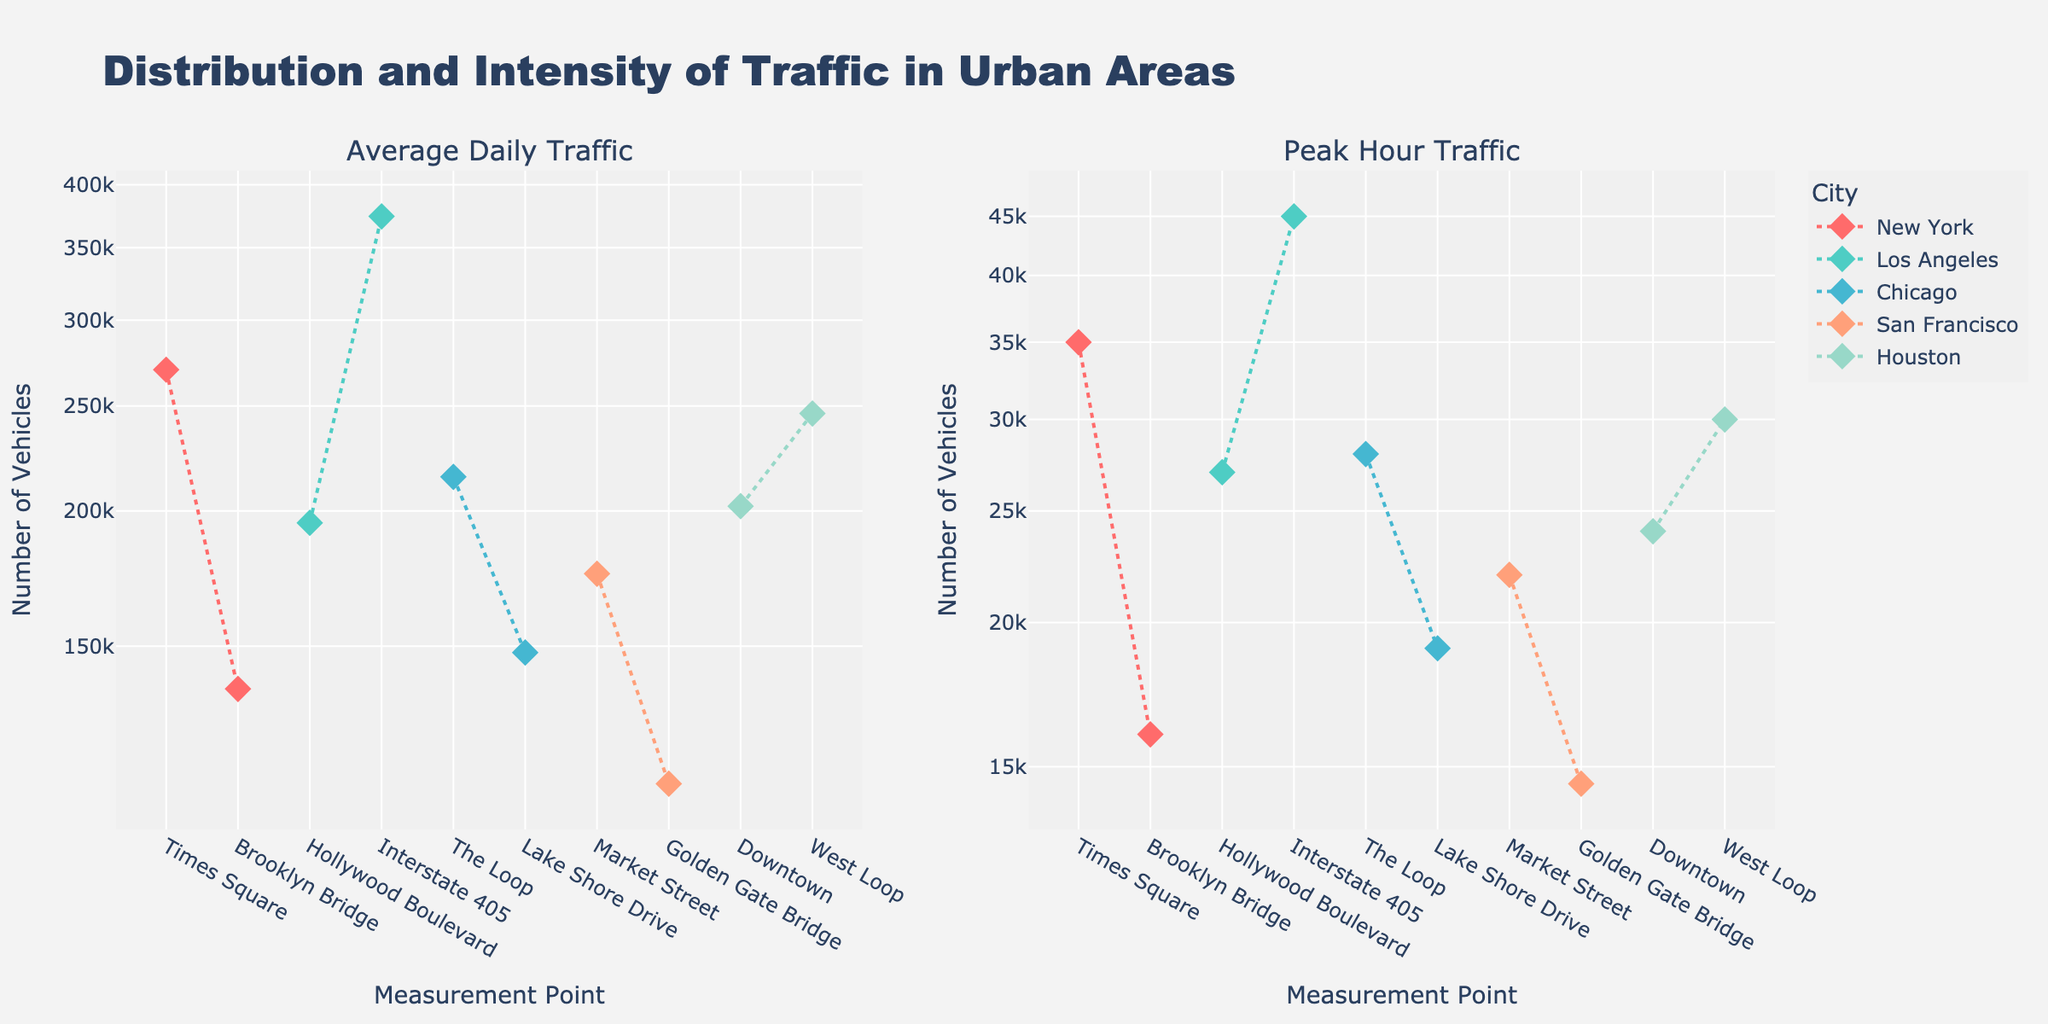Which city has the highest average daily traffic at any measurement point? The subplot on the left shows average daily traffic. The highest point on the vertical axis corresponds to Los Angeles, Interstate 405.
Answer: Los Angeles What is the color used to represent Chicago in the plot? Each city is represented by a distinct color. Chicago is shown using a teal color.
Answer: teal Which measurement point in San Francisco has higher peak hour traffic? In the right subplot (peak hour traffic), compare the two points for San Francisco. Market Street has a higher value.
Answer: Market Street By how much does the average daily traffic at Times Square exceed that at Brooklyn Bridge in New York? Look at the left subplot and compare the y-values for Times Square and Brooklyn Bridge. The difference is 270,000 - 137,000 = 133,000.
Answer: 133,000 Considering both subplots, which city's measurement points are spread out more widely on average daily traffic compared to peak hour traffic? Check the spread of the city's markers for both subplots. Los Angeles seems to have a broader spread on average daily traffic than on peak hour traffic.
Answer: Los Angeles What is the peak hour traffic at The Loop in Chicago? Look at the right subplot and check the y-value for The Loop in Chicago. It reads 28,000.
Answer: 28,000 Which city's average daily traffic has the second-highest value, and what is the value? Excluding the highest, determine the highest remaining value from the left subplot. It is New York, Times Square, with 270,000.
Answer: New York, 270,000 What is the ratio of peak hour traffic to average daily traffic at Golden Gate Bridge in San Francisco? Divide the peak hour traffic by average daily traffic: 14,500 / 112,000.
Answer: 0.129 By how much does the peak hour traffic at Downtown Houston exceed that at Golden Gate Bridge in San Francisco? Look at the right subplot and compare the y-values. The difference is 24,000 - 14,500 = 9,500.
Answer: 9,500 